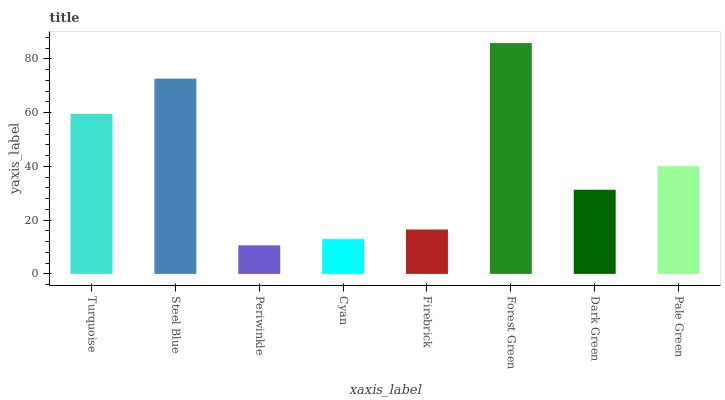Is Periwinkle the minimum?
Answer yes or no. Yes. Is Forest Green the maximum?
Answer yes or no. Yes. Is Steel Blue the minimum?
Answer yes or no. No. Is Steel Blue the maximum?
Answer yes or no. No. Is Steel Blue greater than Turquoise?
Answer yes or no. Yes. Is Turquoise less than Steel Blue?
Answer yes or no. Yes. Is Turquoise greater than Steel Blue?
Answer yes or no. No. Is Steel Blue less than Turquoise?
Answer yes or no. No. Is Pale Green the high median?
Answer yes or no. Yes. Is Dark Green the low median?
Answer yes or no. Yes. Is Turquoise the high median?
Answer yes or no. No. Is Periwinkle the low median?
Answer yes or no. No. 